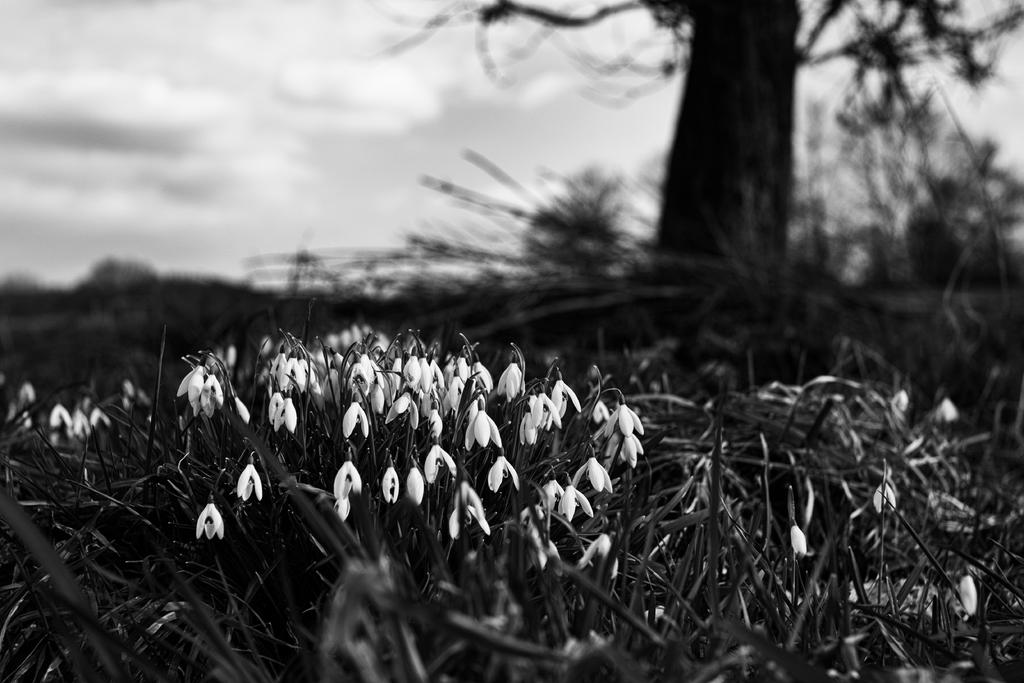What type of living organisms can be seen in the image? Flowers, plants, and a tree are visible in the image. What is the natural setting visible in the image? The natural setting includes flowers, plants, and a tree. What can be seen in the sky in the background of the image? The sky is visible in the background of the image, and there are clouds present. What type of appliance is being used by the fairies in the image? There are no fairies or appliances present in the image. 